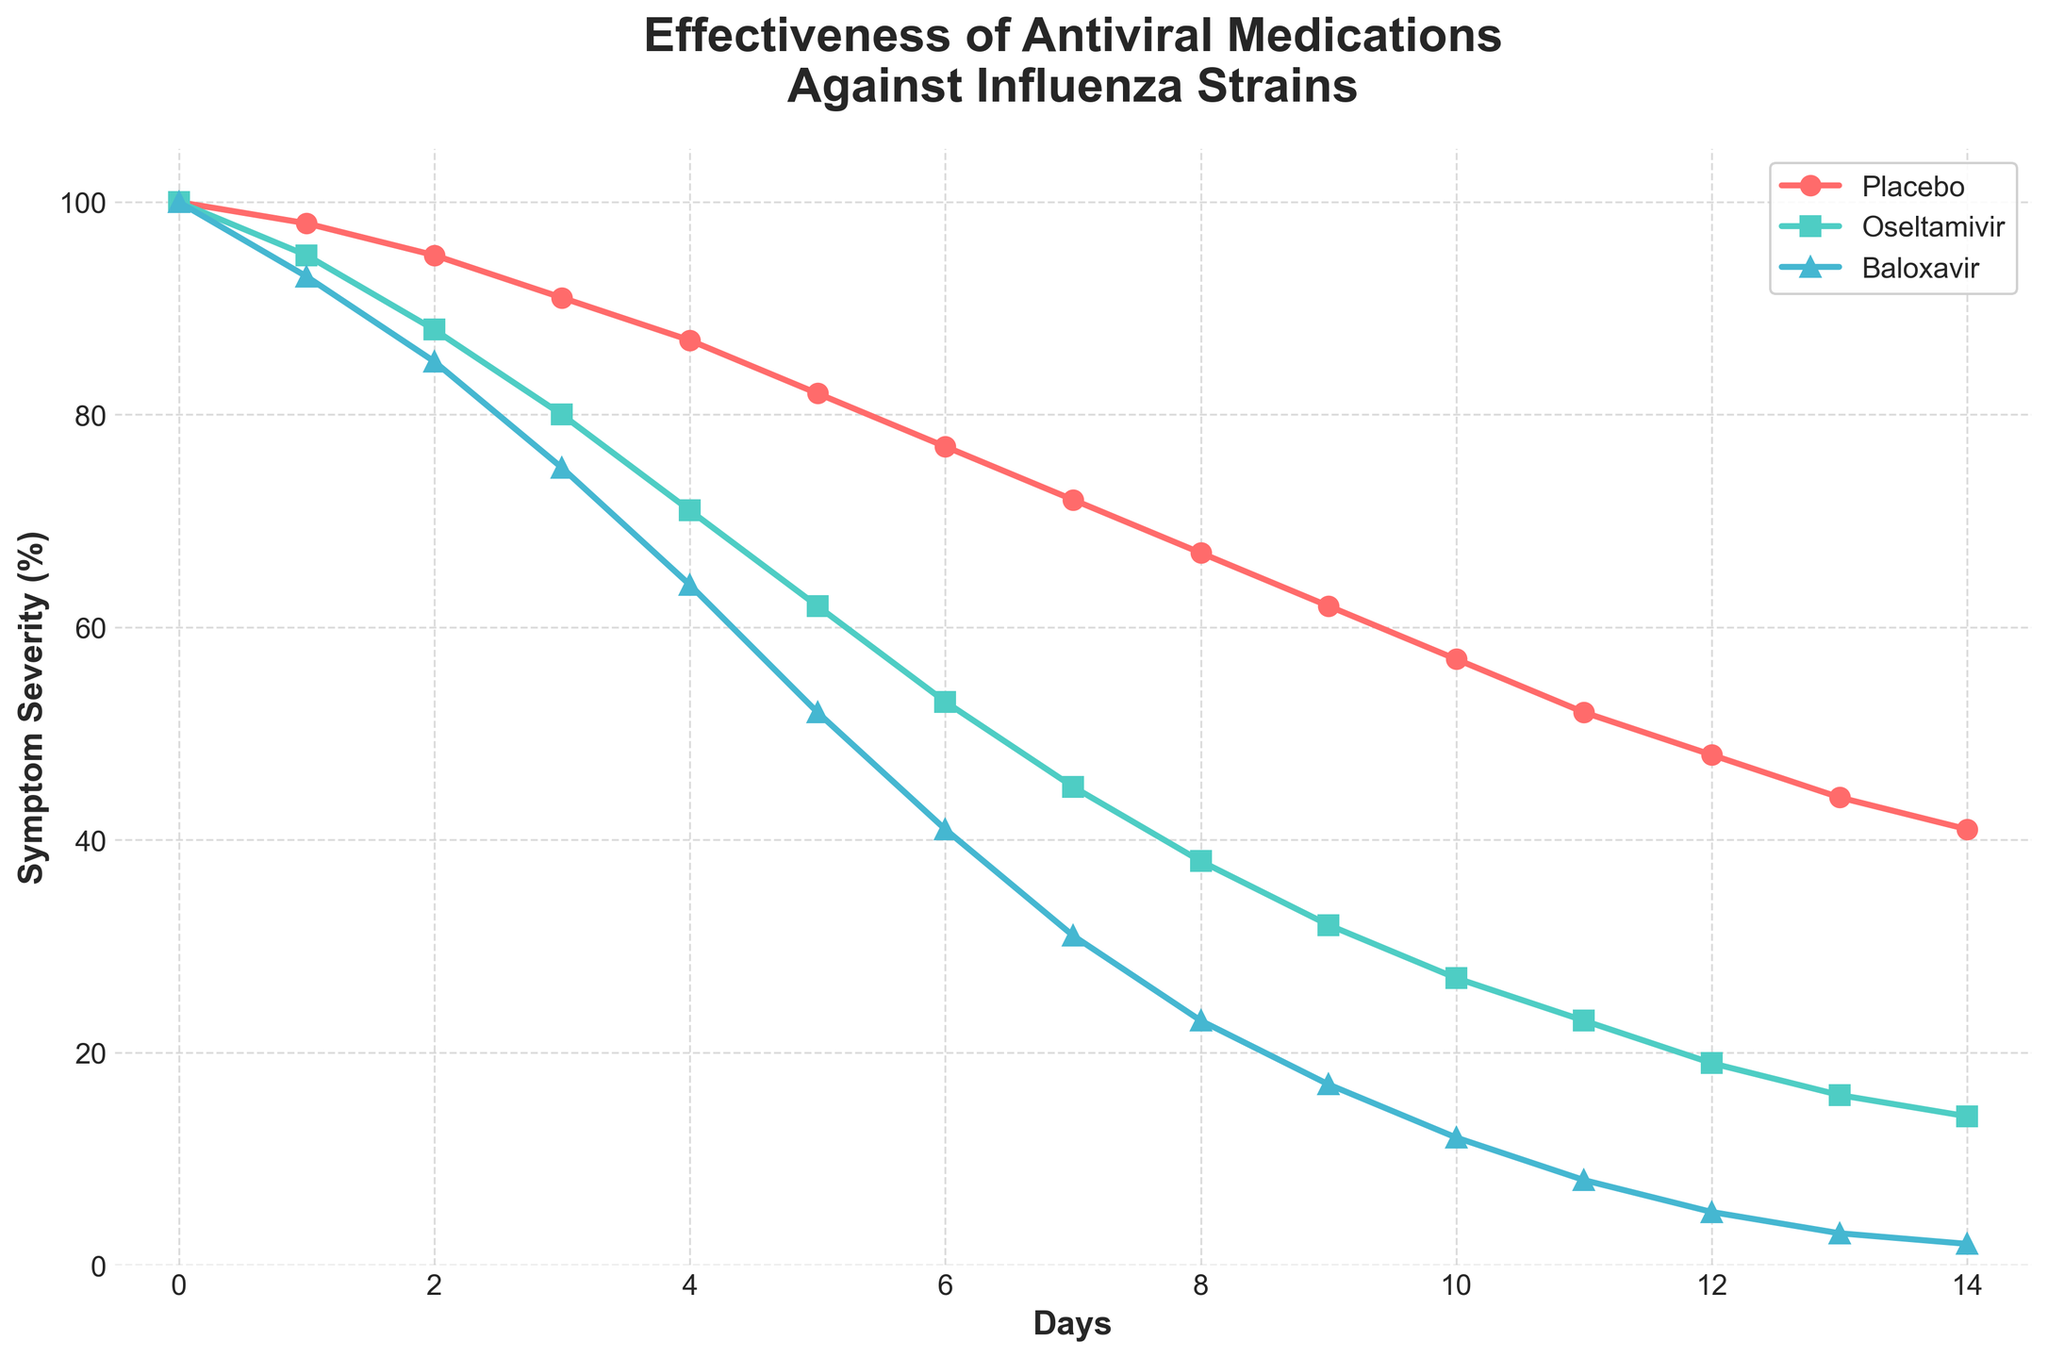What is the symptom severity for the Placebo group on Day 7? To find the severity, locate Day 7 on the x-axis and check the corresponding value for the Placebo group on the y-axis. The value is 72%.
Answer: 72% Which medication shows the fastest reduction in symptoms over the 14-day period? Compare the slopes of the lines representing each medication. Baloxavir shows the steepest decline in symptom severity, indicating the fastest reduction.
Answer: Baloxavir On which day do the symptom severities of Oseltamivir and Baloxavir intersect, if at all? Check if the lines for Oseltamivir and Baloxavir cross each other by following their paths. They do not intersect in the given period.
Answer: They do not intersect What is the difference in symptom severity between the Placebo and Baloxavir groups on Day 10? Find the severity values for both groups on Day 10: Placebo is at 57%, Baloxavir is at 12%. The difference is 57% - 12% = 45%.
Answer: 45% How does the symptom severity on Day 14 compare between Oseltamivir and Baloxavir? On Day 14, Oseltamivir severity is 14% and Baloxavir severity is 2%. Baloxavir has a lower symptom severity by 14% - 2% = 12%.
Answer: Baloxavir is 12% lower What color represents the Placebo group in the chart? Identify the color of the line corresponding to the Placebo group. The Placebo group is represented in red.
Answer: Red At what point in time does the Placebo group's symptom severity drop below 50%? Track the Placebo line to see when it first drops below 50% on the y-axis. This happens just after Day 11, specifically on Day 12.
Answer: Day 12 What is the average symptom severity reduction for Baloxavir over the 14 days? Calculate the difference between Day 0 and Day 14 for Baloxavir: 100% - 2% = 98%. The average daily reduction is 98%/14 days = 7%.
Answer: 7% Which medication shows a symptom severity of approximately 38% on Day 8? Check the y-values for each medication on Day 8. Oseltamivir has a symptom severity of 38%.
Answer: Oseltamivir Between which days does the fastest reduction in symptom severity occur for the Placebo group? Observe the Placebo line to identify the segment with the steepest decline. The steepest drop occurs between Day 0 and Day 1, where it decreases by 100% - 98% = 2%.
Answer: Days 0-1 